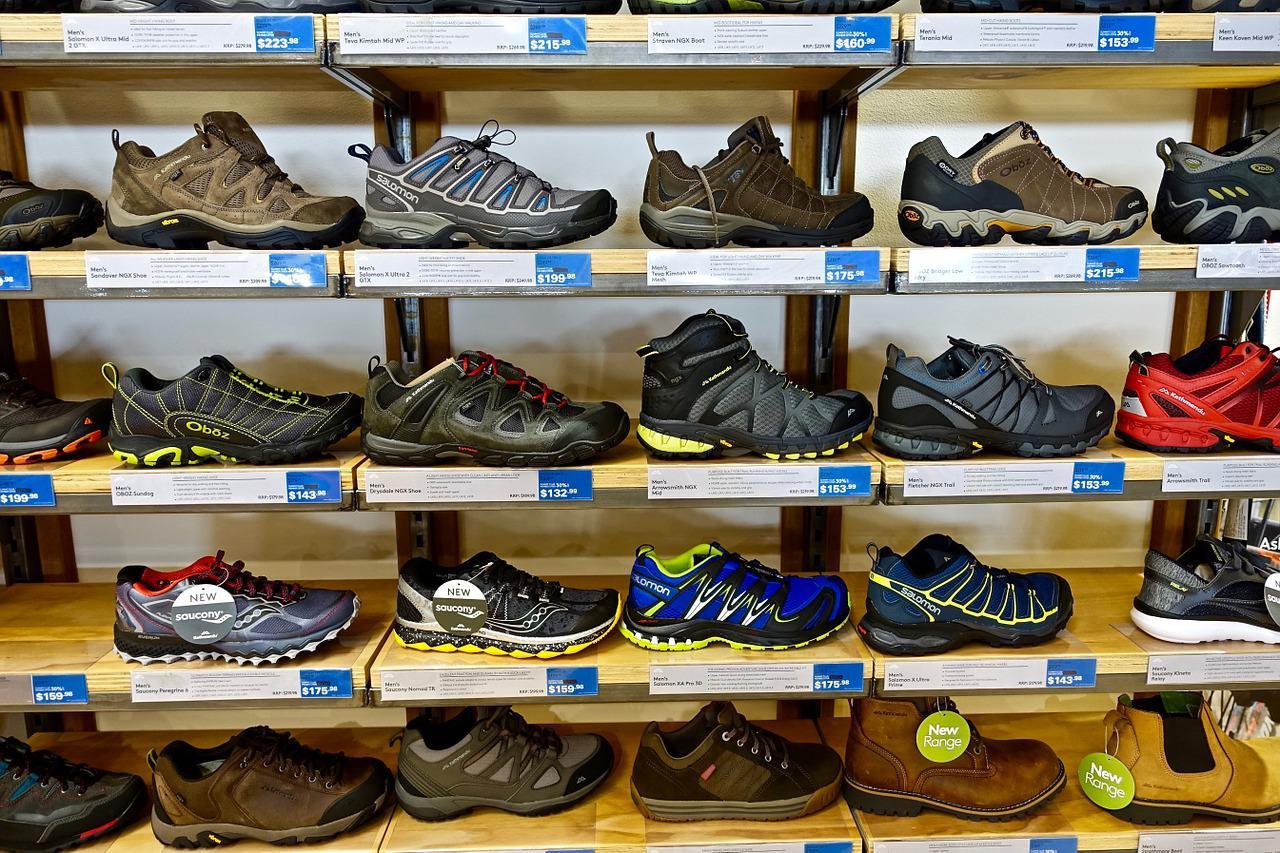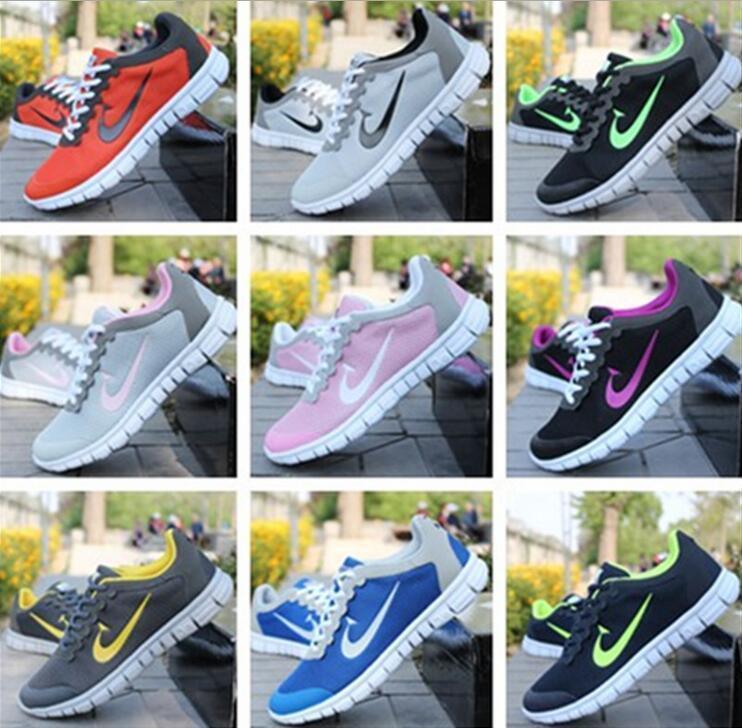The first image is the image on the left, the second image is the image on the right. Examine the images to the left and right. Is the description "the shoes are piled loosely in one of the images" accurate? Answer yes or no. No. 